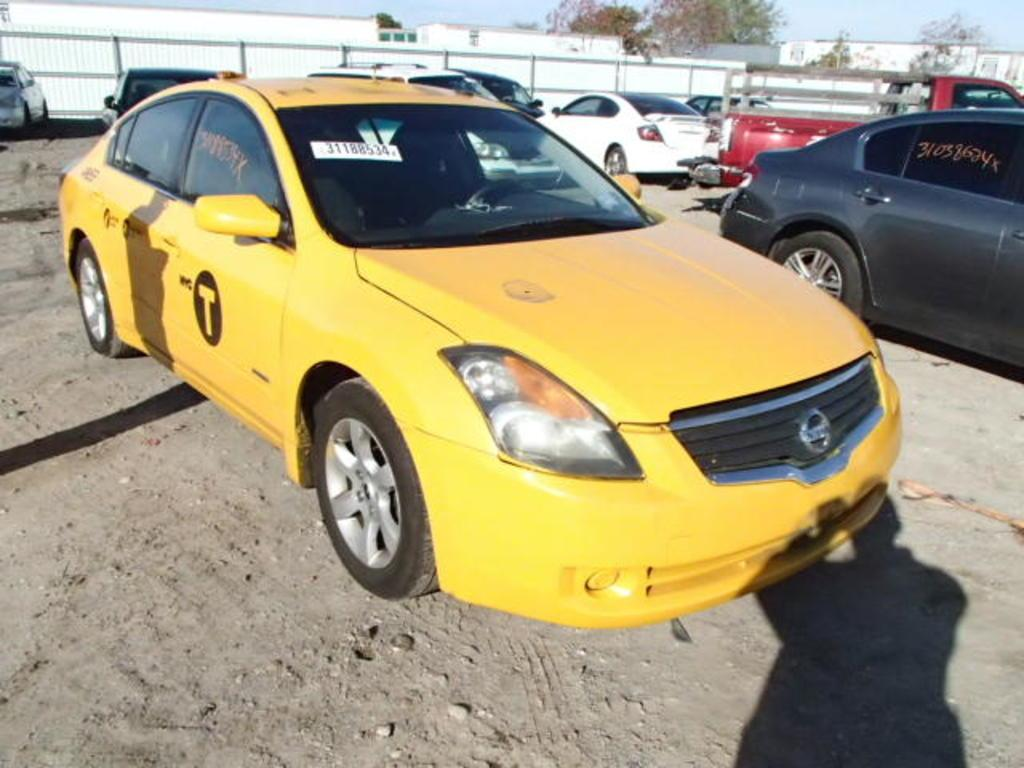<image>
Summarize the visual content of the image. A yellow Nissan with a "T" on the side of it sits in a dirt parking lot. 